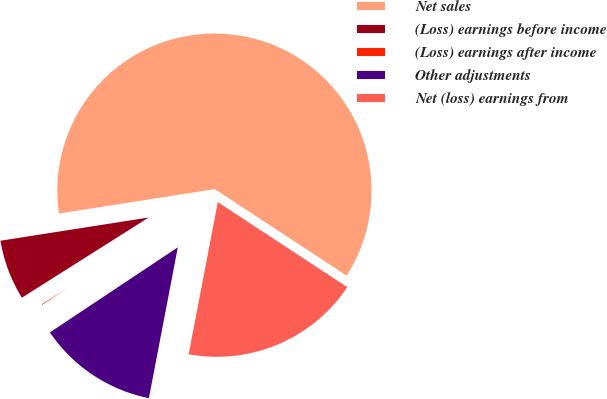Convert chart. <chart><loc_0><loc_0><loc_500><loc_500><pie_chart><fcel>Net sales<fcel>(Loss) earnings before income<fcel>(Loss) earnings after income<fcel>Other adjustments<fcel>Net (loss) earnings from<nl><fcel>61.72%<fcel>6.5%<fcel>0.37%<fcel>12.64%<fcel>18.77%<nl></chart> 